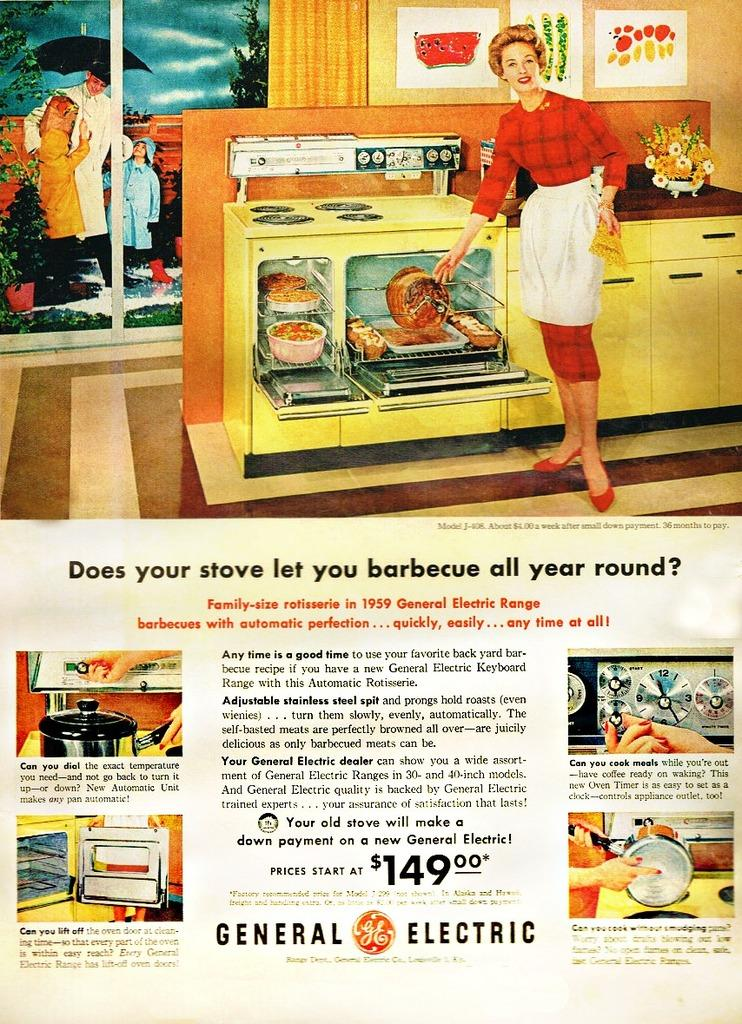Provide a one-sentence caption for the provided image. Vintage General Electric advertising featuring yellow kitchen appliances. 